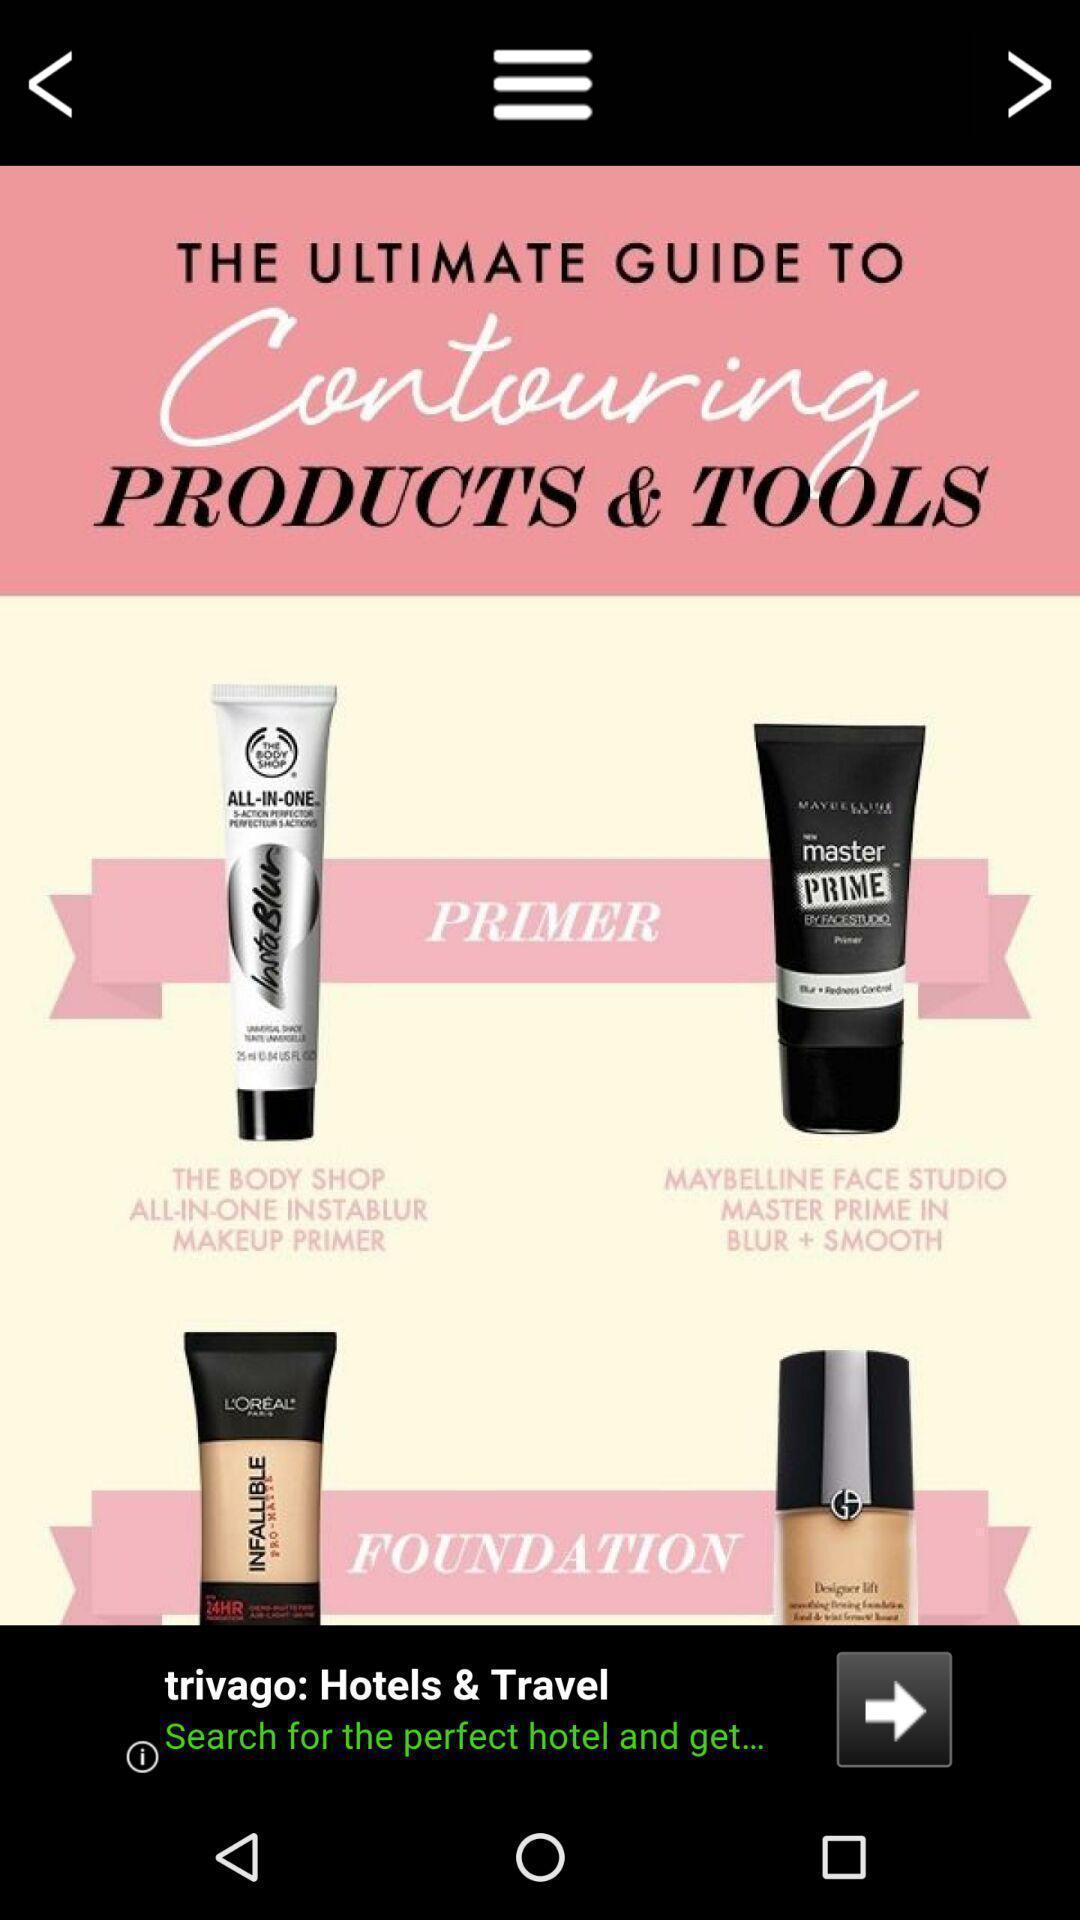Provide a description of this screenshot. Page showing list of items. 